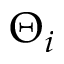Convert formula to latex. <formula><loc_0><loc_0><loc_500><loc_500>\Theta _ { i }</formula> 